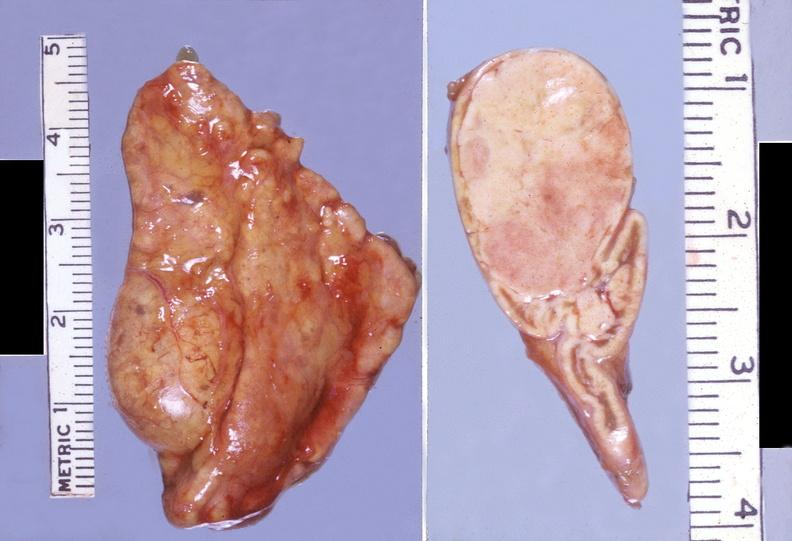s liver present?
Answer the question using a single word or phrase. No 